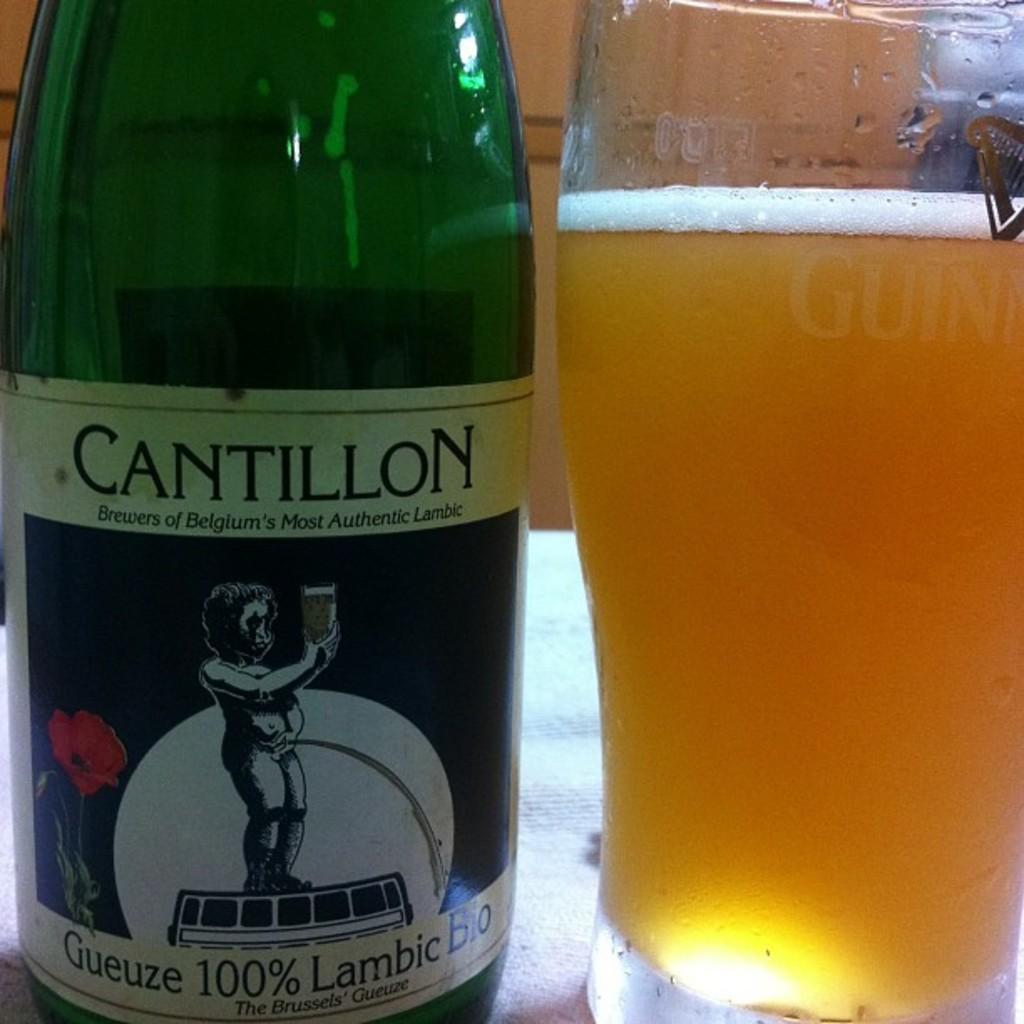Could you give a brief overview of what you see in this image? There is a green glass bottle on the table and a glass beside it. 